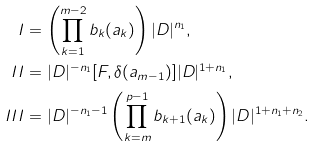<formula> <loc_0><loc_0><loc_500><loc_500>I & = \left ( \prod _ { k = 1 } ^ { m - 2 } b _ { k } ( a _ { k } ) \right ) | D | ^ { n _ { 1 } } , \\ I I & = | D | ^ { - n _ { 1 } } [ F , \delta ( a _ { m - 1 } ) ] | D | ^ { 1 + n _ { 1 } } , \\ I I I & = | D | ^ { - n _ { 1 } - 1 } \left ( \prod _ { k = m } ^ { p - 1 } b _ { k + 1 } ( a _ { k } ) \right ) | D | ^ { 1 + n _ { 1 } + n _ { 2 } } .</formula> 